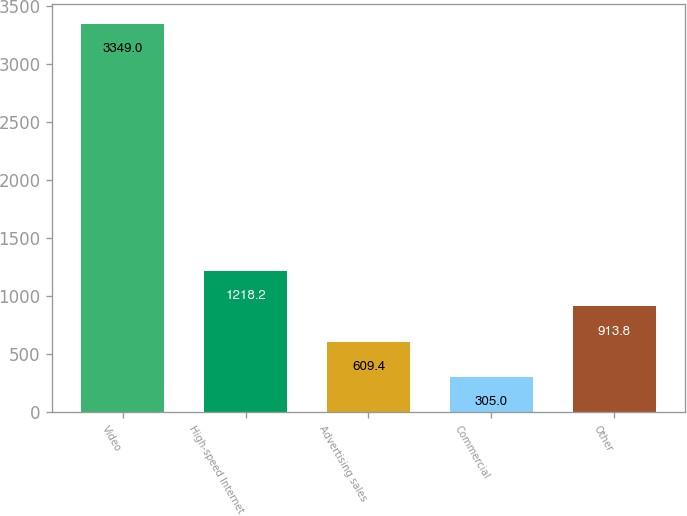<chart> <loc_0><loc_0><loc_500><loc_500><bar_chart><fcel>Video<fcel>High-speed Internet<fcel>Advertising sales<fcel>Commercial<fcel>Other<nl><fcel>3349<fcel>1218.2<fcel>609.4<fcel>305<fcel>913.8<nl></chart> 